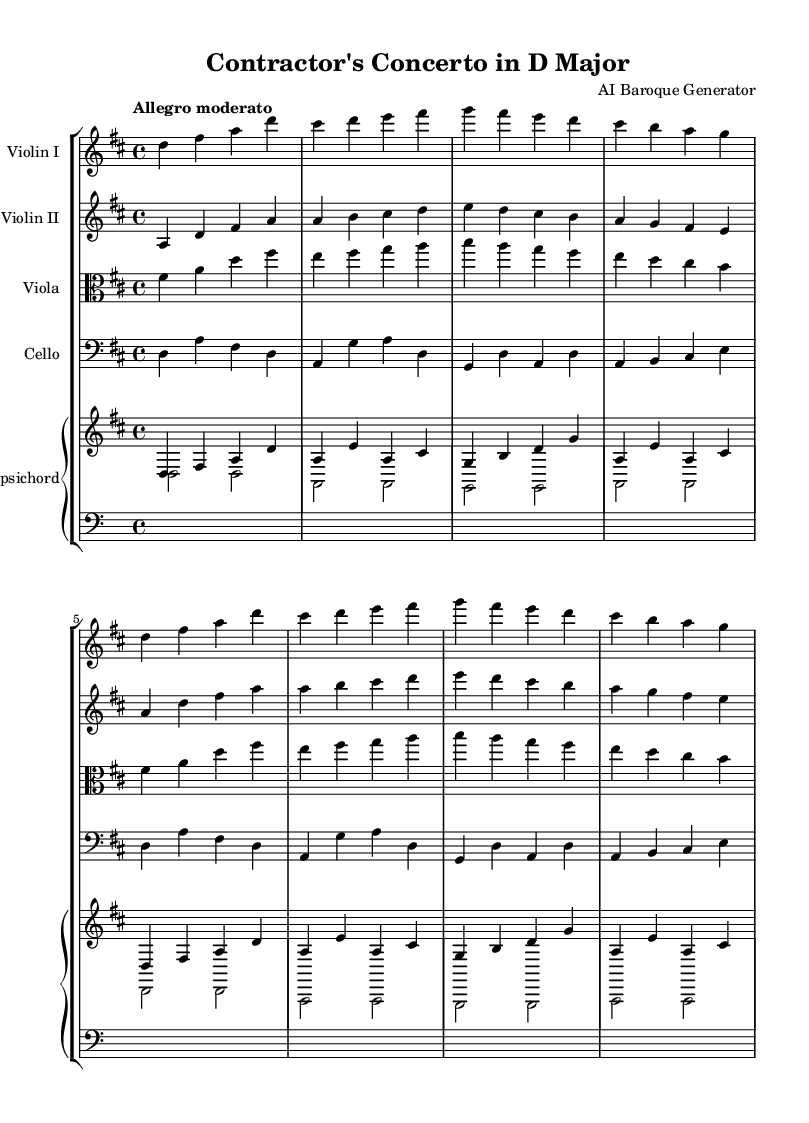What is the key signature of this music? The key signature has two sharps, F# and C#, which indicates that the music is in D major.
Answer: D major What is the time signature of this music? The time signature is represented by the symbol at the beginning of the score, which shows four beats in each measure; this is indicated by the 4/4 symbol.
Answer: 4/4 What is the tempo marking of this piece? The tempo marking at the beginning of the score indicates that the piece should be played at a moderate pace, described as "Allegro moderato."
Answer: Allegro moderato How many instruments are scored in this piece? By examining the score layout, there are five distinct instruments represented: two violins, one viola, one cello, and one harpsichord.
Answer: Five What is the range of the cello part indicated by the bass clef? The cello part starts from the note D below middle C and extends up to the note D above middle C, providing a reference to its range in the music.
Answer: D to D What is the main texture of this Baroque chamber music? The texture is characterized primarily by polyphony, where multiple independent melodies are played simultaneously by different instruments, consistent with Baroque style.
Answer: Polyphony What sections are repeated in the violins? The violin parts show repetition of melodic phrases, specifically the first eight bars are restated in the subsequent section, demonstrating a common feature in Baroque compositions of thematic development.
Answer: First eight bars 